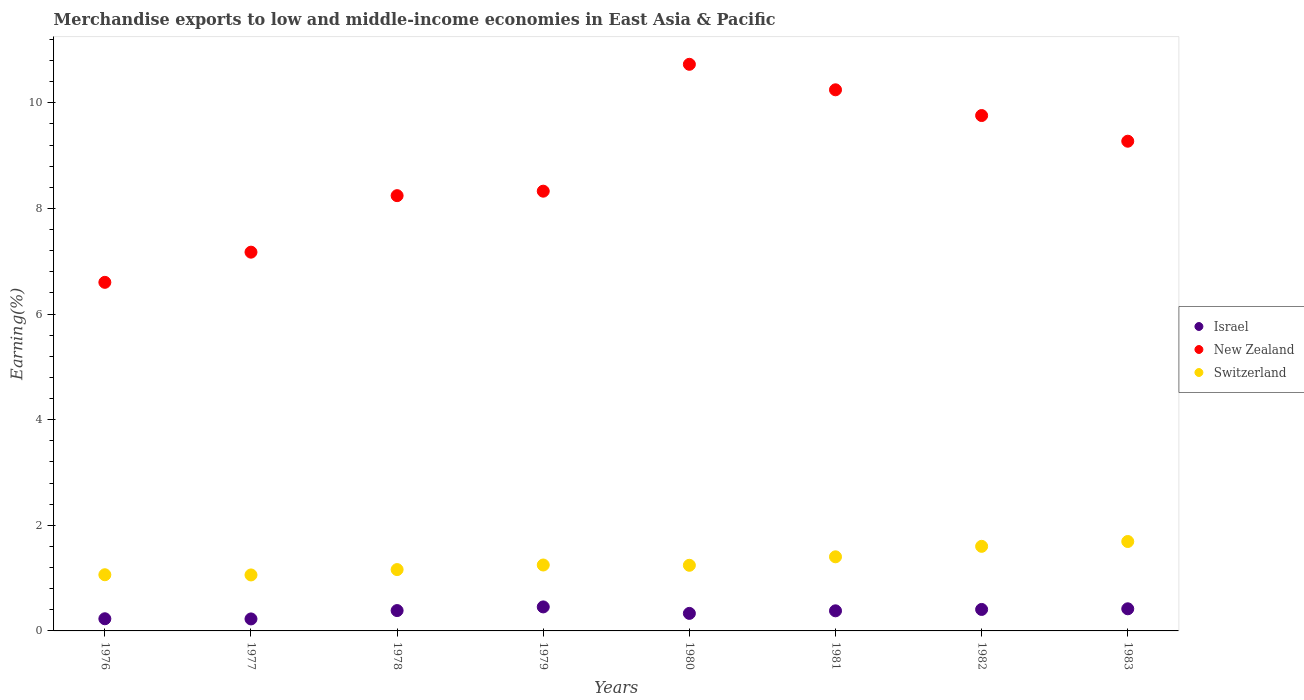How many different coloured dotlines are there?
Your response must be concise. 3. What is the percentage of amount earned from merchandise exports in Israel in 1978?
Make the answer very short. 0.39. Across all years, what is the maximum percentage of amount earned from merchandise exports in Switzerland?
Ensure brevity in your answer.  1.69. Across all years, what is the minimum percentage of amount earned from merchandise exports in Israel?
Keep it short and to the point. 0.23. In which year was the percentage of amount earned from merchandise exports in New Zealand maximum?
Your answer should be very brief. 1980. What is the total percentage of amount earned from merchandise exports in New Zealand in the graph?
Provide a short and direct response. 70.34. What is the difference between the percentage of amount earned from merchandise exports in Israel in 1976 and that in 1980?
Keep it short and to the point. -0.1. What is the difference between the percentage of amount earned from merchandise exports in New Zealand in 1979 and the percentage of amount earned from merchandise exports in Israel in 1981?
Your response must be concise. 7.95. What is the average percentage of amount earned from merchandise exports in Switzerland per year?
Give a very brief answer. 1.31. In the year 1983, what is the difference between the percentage of amount earned from merchandise exports in Israel and percentage of amount earned from merchandise exports in Switzerland?
Provide a short and direct response. -1.27. In how many years, is the percentage of amount earned from merchandise exports in New Zealand greater than 1.6 %?
Your response must be concise. 8. What is the ratio of the percentage of amount earned from merchandise exports in New Zealand in 1976 to that in 1979?
Your answer should be compact. 0.79. Is the percentage of amount earned from merchandise exports in New Zealand in 1978 less than that in 1979?
Provide a succinct answer. Yes. Is the difference between the percentage of amount earned from merchandise exports in Israel in 1977 and 1981 greater than the difference between the percentage of amount earned from merchandise exports in Switzerland in 1977 and 1981?
Offer a very short reply. Yes. What is the difference between the highest and the second highest percentage of amount earned from merchandise exports in New Zealand?
Your response must be concise. 0.48. What is the difference between the highest and the lowest percentage of amount earned from merchandise exports in Israel?
Provide a short and direct response. 0.23. Is the sum of the percentage of amount earned from merchandise exports in Israel in 1978 and 1979 greater than the maximum percentage of amount earned from merchandise exports in Switzerland across all years?
Your response must be concise. No. Is the percentage of amount earned from merchandise exports in Israel strictly greater than the percentage of amount earned from merchandise exports in Switzerland over the years?
Your answer should be compact. No. Is the percentage of amount earned from merchandise exports in New Zealand strictly less than the percentage of amount earned from merchandise exports in Israel over the years?
Give a very brief answer. No. How many years are there in the graph?
Provide a succinct answer. 8. What is the difference between two consecutive major ticks on the Y-axis?
Offer a terse response. 2. Does the graph contain any zero values?
Keep it short and to the point. No. Does the graph contain grids?
Give a very brief answer. No. How many legend labels are there?
Keep it short and to the point. 3. How are the legend labels stacked?
Make the answer very short. Vertical. What is the title of the graph?
Provide a short and direct response. Merchandise exports to low and middle-income economies in East Asia & Pacific. Does "Belarus" appear as one of the legend labels in the graph?
Your answer should be very brief. No. What is the label or title of the Y-axis?
Your answer should be compact. Earning(%). What is the Earning(%) of Israel in 1976?
Ensure brevity in your answer.  0.23. What is the Earning(%) of New Zealand in 1976?
Offer a terse response. 6.6. What is the Earning(%) in Switzerland in 1976?
Make the answer very short. 1.06. What is the Earning(%) of Israel in 1977?
Offer a terse response. 0.23. What is the Earning(%) in New Zealand in 1977?
Your response must be concise. 7.17. What is the Earning(%) of Switzerland in 1977?
Your answer should be very brief. 1.06. What is the Earning(%) in Israel in 1978?
Make the answer very short. 0.39. What is the Earning(%) of New Zealand in 1978?
Make the answer very short. 8.24. What is the Earning(%) in Switzerland in 1978?
Make the answer very short. 1.16. What is the Earning(%) of Israel in 1979?
Ensure brevity in your answer.  0.45. What is the Earning(%) in New Zealand in 1979?
Make the answer very short. 8.33. What is the Earning(%) in Switzerland in 1979?
Offer a very short reply. 1.25. What is the Earning(%) in Israel in 1980?
Your answer should be very brief. 0.33. What is the Earning(%) of New Zealand in 1980?
Provide a short and direct response. 10.73. What is the Earning(%) in Switzerland in 1980?
Give a very brief answer. 1.24. What is the Earning(%) in Israel in 1981?
Make the answer very short. 0.38. What is the Earning(%) of New Zealand in 1981?
Your answer should be compact. 10.25. What is the Earning(%) of Switzerland in 1981?
Your response must be concise. 1.4. What is the Earning(%) in Israel in 1982?
Provide a succinct answer. 0.41. What is the Earning(%) in New Zealand in 1982?
Offer a terse response. 9.76. What is the Earning(%) in Switzerland in 1982?
Provide a succinct answer. 1.6. What is the Earning(%) of Israel in 1983?
Make the answer very short. 0.42. What is the Earning(%) in New Zealand in 1983?
Offer a terse response. 9.27. What is the Earning(%) in Switzerland in 1983?
Offer a terse response. 1.69. Across all years, what is the maximum Earning(%) of Israel?
Ensure brevity in your answer.  0.45. Across all years, what is the maximum Earning(%) in New Zealand?
Your answer should be very brief. 10.73. Across all years, what is the maximum Earning(%) in Switzerland?
Make the answer very short. 1.69. Across all years, what is the minimum Earning(%) of Israel?
Ensure brevity in your answer.  0.23. Across all years, what is the minimum Earning(%) in New Zealand?
Offer a very short reply. 6.6. Across all years, what is the minimum Earning(%) of Switzerland?
Keep it short and to the point. 1.06. What is the total Earning(%) in Israel in the graph?
Your response must be concise. 2.84. What is the total Earning(%) of New Zealand in the graph?
Your answer should be very brief. 70.34. What is the total Earning(%) in Switzerland in the graph?
Keep it short and to the point. 10.47. What is the difference between the Earning(%) of Israel in 1976 and that in 1977?
Provide a short and direct response. 0. What is the difference between the Earning(%) in New Zealand in 1976 and that in 1977?
Make the answer very short. -0.57. What is the difference between the Earning(%) of Switzerland in 1976 and that in 1977?
Your answer should be very brief. 0. What is the difference between the Earning(%) of Israel in 1976 and that in 1978?
Give a very brief answer. -0.16. What is the difference between the Earning(%) in New Zealand in 1976 and that in 1978?
Provide a short and direct response. -1.64. What is the difference between the Earning(%) in Switzerland in 1976 and that in 1978?
Offer a very short reply. -0.1. What is the difference between the Earning(%) in Israel in 1976 and that in 1979?
Provide a succinct answer. -0.22. What is the difference between the Earning(%) in New Zealand in 1976 and that in 1979?
Make the answer very short. -1.73. What is the difference between the Earning(%) of Switzerland in 1976 and that in 1979?
Offer a terse response. -0.18. What is the difference between the Earning(%) of Israel in 1976 and that in 1980?
Offer a very short reply. -0.1. What is the difference between the Earning(%) of New Zealand in 1976 and that in 1980?
Keep it short and to the point. -4.13. What is the difference between the Earning(%) in Switzerland in 1976 and that in 1980?
Ensure brevity in your answer.  -0.18. What is the difference between the Earning(%) of Israel in 1976 and that in 1981?
Provide a short and direct response. -0.15. What is the difference between the Earning(%) in New Zealand in 1976 and that in 1981?
Make the answer very short. -3.65. What is the difference between the Earning(%) of Switzerland in 1976 and that in 1981?
Provide a short and direct response. -0.34. What is the difference between the Earning(%) of Israel in 1976 and that in 1982?
Provide a succinct answer. -0.18. What is the difference between the Earning(%) of New Zealand in 1976 and that in 1982?
Offer a terse response. -3.16. What is the difference between the Earning(%) of Switzerland in 1976 and that in 1982?
Give a very brief answer. -0.54. What is the difference between the Earning(%) of Israel in 1976 and that in 1983?
Keep it short and to the point. -0.19. What is the difference between the Earning(%) of New Zealand in 1976 and that in 1983?
Provide a succinct answer. -2.67. What is the difference between the Earning(%) in Switzerland in 1976 and that in 1983?
Offer a terse response. -0.63. What is the difference between the Earning(%) of Israel in 1977 and that in 1978?
Your answer should be very brief. -0.16. What is the difference between the Earning(%) in New Zealand in 1977 and that in 1978?
Make the answer very short. -1.07. What is the difference between the Earning(%) in Switzerland in 1977 and that in 1978?
Make the answer very short. -0.1. What is the difference between the Earning(%) of Israel in 1977 and that in 1979?
Provide a succinct answer. -0.23. What is the difference between the Earning(%) of New Zealand in 1977 and that in 1979?
Provide a short and direct response. -1.15. What is the difference between the Earning(%) of Switzerland in 1977 and that in 1979?
Give a very brief answer. -0.19. What is the difference between the Earning(%) of Israel in 1977 and that in 1980?
Keep it short and to the point. -0.1. What is the difference between the Earning(%) in New Zealand in 1977 and that in 1980?
Keep it short and to the point. -3.56. What is the difference between the Earning(%) of Switzerland in 1977 and that in 1980?
Offer a very short reply. -0.18. What is the difference between the Earning(%) in Israel in 1977 and that in 1981?
Provide a short and direct response. -0.15. What is the difference between the Earning(%) of New Zealand in 1977 and that in 1981?
Provide a short and direct response. -3.07. What is the difference between the Earning(%) of Switzerland in 1977 and that in 1981?
Ensure brevity in your answer.  -0.34. What is the difference between the Earning(%) in Israel in 1977 and that in 1982?
Offer a terse response. -0.18. What is the difference between the Earning(%) of New Zealand in 1977 and that in 1982?
Your answer should be compact. -2.59. What is the difference between the Earning(%) in Switzerland in 1977 and that in 1982?
Provide a short and direct response. -0.54. What is the difference between the Earning(%) of Israel in 1977 and that in 1983?
Provide a short and direct response. -0.19. What is the difference between the Earning(%) of New Zealand in 1977 and that in 1983?
Provide a short and direct response. -2.1. What is the difference between the Earning(%) in Switzerland in 1977 and that in 1983?
Provide a short and direct response. -0.63. What is the difference between the Earning(%) of Israel in 1978 and that in 1979?
Provide a short and direct response. -0.07. What is the difference between the Earning(%) of New Zealand in 1978 and that in 1979?
Offer a very short reply. -0.08. What is the difference between the Earning(%) in Switzerland in 1978 and that in 1979?
Provide a succinct answer. -0.09. What is the difference between the Earning(%) in Israel in 1978 and that in 1980?
Ensure brevity in your answer.  0.05. What is the difference between the Earning(%) in New Zealand in 1978 and that in 1980?
Make the answer very short. -2.49. What is the difference between the Earning(%) of Switzerland in 1978 and that in 1980?
Provide a succinct answer. -0.08. What is the difference between the Earning(%) in Israel in 1978 and that in 1981?
Provide a short and direct response. 0. What is the difference between the Earning(%) in New Zealand in 1978 and that in 1981?
Your response must be concise. -2. What is the difference between the Earning(%) in Switzerland in 1978 and that in 1981?
Offer a terse response. -0.24. What is the difference between the Earning(%) of Israel in 1978 and that in 1982?
Keep it short and to the point. -0.02. What is the difference between the Earning(%) in New Zealand in 1978 and that in 1982?
Make the answer very short. -1.52. What is the difference between the Earning(%) in Switzerland in 1978 and that in 1982?
Offer a very short reply. -0.44. What is the difference between the Earning(%) in Israel in 1978 and that in 1983?
Offer a terse response. -0.03. What is the difference between the Earning(%) in New Zealand in 1978 and that in 1983?
Your answer should be compact. -1.03. What is the difference between the Earning(%) in Switzerland in 1978 and that in 1983?
Offer a very short reply. -0.53. What is the difference between the Earning(%) in Israel in 1979 and that in 1980?
Ensure brevity in your answer.  0.12. What is the difference between the Earning(%) of New Zealand in 1979 and that in 1980?
Offer a very short reply. -2.4. What is the difference between the Earning(%) in Switzerland in 1979 and that in 1980?
Keep it short and to the point. 0.01. What is the difference between the Earning(%) in Israel in 1979 and that in 1981?
Your answer should be compact. 0.07. What is the difference between the Earning(%) in New Zealand in 1979 and that in 1981?
Your answer should be very brief. -1.92. What is the difference between the Earning(%) of Switzerland in 1979 and that in 1981?
Provide a succinct answer. -0.16. What is the difference between the Earning(%) in Israel in 1979 and that in 1982?
Provide a succinct answer. 0.05. What is the difference between the Earning(%) in New Zealand in 1979 and that in 1982?
Provide a short and direct response. -1.43. What is the difference between the Earning(%) in Switzerland in 1979 and that in 1982?
Your answer should be compact. -0.35. What is the difference between the Earning(%) of Israel in 1979 and that in 1983?
Your response must be concise. 0.04. What is the difference between the Earning(%) of New Zealand in 1979 and that in 1983?
Offer a very short reply. -0.95. What is the difference between the Earning(%) of Switzerland in 1979 and that in 1983?
Your answer should be very brief. -0.44. What is the difference between the Earning(%) in Israel in 1980 and that in 1981?
Provide a short and direct response. -0.05. What is the difference between the Earning(%) of New Zealand in 1980 and that in 1981?
Provide a short and direct response. 0.48. What is the difference between the Earning(%) in Switzerland in 1980 and that in 1981?
Ensure brevity in your answer.  -0.16. What is the difference between the Earning(%) in Israel in 1980 and that in 1982?
Provide a short and direct response. -0.07. What is the difference between the Earning(%) in New Zealand in 1980 and that in 1982?
Provide a short and direct response. 0.97. What is the difference between the Earning(%) of Switzerland in 1980 and that in 1982?
Provide a succinct answer. -0.36. What is the difference between the Earning(%) of Israel in 1980 and that in 1983?
Your response must be concise. -0.09. What is the difference between the Earning(%) in New Zealand in 1980 and that in 1983?
Your answer should be compact. 1.46. What is the difference between the Earning(%) in Switzerland in 1980 and that in 1983?
Offer a very short reply. -0.45. What is the difference between the Earning(%) in Israel in 1981 and that in 1982?
Your answer should be compact. -0.03. What is the difference between the Earning(%) in New Zealand in 1981 and that in 1982?
Provide a succinct answer. 0.49. What is the difference between the Earning(%) of Switzerland in 1981 and that in 1982?
Offer a very short reply. -0.2. What is the difference between the Earning(%) in Israel in 1981 and that in 1983?
Keep it short and to the point. -0.04. What is the difference between the Earning(%) of New Zealand in 1981 and that in 1983?
Offer a very short reply. 0.97. What is the difference between the Earning(%) in Switzerland in 1981 and that in 1983?
Give a very brief answer. -0.29. What is the difference between the Earning(%) in Israel in 1982 and that in 1983?
Offer a very short reply. -0.01. What is the difference between the Earning(%) of New Zealand in 1982 and that in 1983?
Ensure brevity in your answer.  0.49. What is the difference between the Earning(%) of Switzerland in 1982 and that in 1983?
Your answer should be compact. -0.09. What is the difference between the Earning(%) in Israel in 1976 and the Earning(%) in New Zealand in 1977?
Offer a very short reply. -6.94. What is the difference between the Earning(%) of Israel in 1976 and the Earning(%) of Switzerland in 1977?
Offer a terse response. -0.83. What is the difference between the Earning(%) in New Zealand in 1976 and the Earning(%) in Switzerland in 1977?
Your response must be concise. 5.54. What is the difference between the Earning(%) in Israel in 1976 and the Earning(%) in New Zealand in 1978?
Your response must be concise. -8.01. What is the difference between the Earning(%) in Israel in 1976 and the Earning(%) in Switzerland in 1978?
Your answer should be compact. -0.93. What is the difference between the Earning(%) in New Zealand in 1976 and the Earning(%) in Switzerland in 1978?
Offer a terse response. 5.44. What is the difference between the Earning(%) of Israel in 1976 and the Earning(%) of New Zealand in 1979?
Offer a very short reply. -8.1. What is the difference between the Earning(%) in Israel in 1976 and the Earning(%) in Switzerland in 1979?
Your response must be concise. -1.02. What is the difference between the Earning(%) in New Zealand in 1976 and the Earning(%) in Switzerland in 1979?
Ensure brevity in your answer.  5.35. What is the difference between the Earning(%) of Israel in 1976 and the Earning(%) of New Zealand in 1980?
Your answer should be compact. -10.5. What is the difference between the Earning(%) in Israel in 1976 and the Earning(%) in Switzerland in 1980?
Your answer should be compact. -1.01. What is the difference between the Earning(%) of New Zealand in 1976 and the Earning(%) of Switzerland in 1980?
Provide a succinct answer. 5.36. What is the difference between the Earning(%) in Israel in 1976 and the Earning(%) in New Zealand in 1981?
Provide a short and direct response. -10.02. What is the difference between the Earning(%) in Israel in 1976 and the Earning(%) in Switzerland in 1981?
Offer a terse response. -1.17. What is the difference between the Earning(%) of New Zealand in 1976 and the Earning(%) of Switzerland in 1981?
Ensure brevity in your answer.  5.2. What is the difference between the Earning(%) in Israel in 1976 and the Earning(%) in New Zealand in 1982?
Keep it short and to the point. -9.53. What is the difference between the Earning(%) in Israel in 1976 and the Earning(%) in Switzerland in 1982?
Give a very brief answer. -1.37. What is the difference between the Earning(%) of New Zealand in 1976 and the Earning(%) of Switzerland in 1982?
Provide a short and direct response. 5. What is the difference between the Earning(%) of Israel in 1976 and the Earning(%) of New Zealand in 1983?
Give a very brief answer. -9.04. What is the difference between the Earning(%) of Israel in 1976 and the Earning(%) of Switzerland in 1983?
Offer a terse response. -1.46. What is the difference between the Earning(%) in New Zealand in 1976 and the Earning(%) in Switzerland in 1983?
Your response must be concise. 4.91. What is the difference between the Earning(%) in Israel in 1977 and the Earning(%) in New Zealand in 1978?
Your answer should be compact. -8.01. What is the difference between the Earning(%) of Israel in 1977 and the Earning(%) of Switzerland in 1978?
Offer a very short reply. -0.93. What is the difference between the Earning(%) in New Zealand in 1977 and the Earning(%) in Switzerland in 1978?
Ensure brevity in your answer.  6.01. What is the difference between the Earning(%) in Israel in 1977 and the Earning(%) in New Zealand in 1979?
Provide a succinct answer. -8.1. What is the difference between the Earning(%) in Israel in 1977 and the Earning(%) in Switzerland in 1979?
Give a very brief answer. -1.02. What is the difference between the Earning(%) in New Zealand in 1977 and the Earning(%) in Switzerland in 1979?
Your answer should be very brief. 5.92. What is the difference between the Earning(%) of Israel in 1977 and the Earning(%) of New Zealand in 1980?
Your response must be concise. -10.5. What is the difference between the Earning(%) in Israel in 1977 and the Earning(%) in Switzerland in 1980?
Give a very brief answer. -1.02. What is the difference between the Earning(%) of New Zealand in 1977 and the Earning(%) of Switzerland in 1980?
Your answer should be compact. 5.93. What is the difference between the Earning(%) in Israel in 1977 and the Earning(%) in New Zealand in 1981?
Make the answer very short. -10.02. What is the difference between the Earning(%) of Israel in 1977 and the Earning(%) of Switzerland in 1981?
Your answer should be compact. -1.18. What is the difference between the Earning(%) of New Zealand in 1977 and the Earning(%) of Switzerland in 1981?
Offer a very short reply. 5.77. What is the difference between the Earning(%) of Israel in 1977 and the Earning(%) of New Zealand in 1982?
Your response must be concise. -9.53. What is the difference between the Earning(%) in Israel in 1977 and the Earning(%) in Switzerland in 1982?
Provide a succinct answer. -1.37. What is the difference between the Earning(%) in New Zealand in 1977 and the Earning(%) in Switzerland in 1982?
Give a very brief answer. 5.57. What is the difference between the Earning(%) of Israel in 1977 and the Earning(%) of New Zealand in 1983?
Your response must be concise. -9.04. What is the difference between the Earning(%) of Israel in 1977 and the Earning(%) of Switzerland in 1983?
Your response must be concise. -1.47. What is the difference between the Earning(%) of New Zealand in 1977 and the Earning(%) of Switzerland in 1983?
Keep it short and to the point. 5.48. What is the difference between the Earning(%) of Israel in 1978 and the Earning(%) of New Zealand in 1979?
Keep it short and to the point. -7.94. What is the difference between the Earning(%) in Israel in 1978 and the Earning(%) in Switzerland in 1979?
Make the answer very short. -0.86. What is the difference between the Earning(%) of New Zealand in 1978 and the Earning(%) of Switzerland in 1979?
Provide a succinct answer. 6.99. What is the difference between the Earning(%) of Israel in 1978 and the Earning(%) of New Zealand in 1980?
Your response must be concise. -10.34. What is the difference between the Earning(%) in Israel in 1978 and the Earning(%) in Switzerland in 1980?
Your answer should be compact. -0.86. What is the difference between the Earning(%) in New Zealand in 1978 and the Earning(%) in Switzerland in 1980?
Give a very brief answer. 7. What is the difference between the Earning(%) in Israel in 1978 and the Earning(%) in New Zealand in 1981?
Keep it short and to the point. -9.86. What is the difference between the Earning(%) in Israel in 1978 and the Earning(%) in Switzerland in 1981?
Give a very brief answer. -1.02. What is the difference between the Earning(%) in New Zealand in 1978 and the Earning(%) in Switzerland in 1981?
Give a very brief answer. 6.84. What is the difference between the Earning(%) of Israel in 1978 and the Earning(%) of New Zealand in 1982?
Keep it short and to the point. -9.37. What is the difference between the Earning(%) in Israel in 1978 and the Earning(%) in Switzerland in 1982?
Your response must be concise. -1.22. What is the difference between the Earning(%) in New Zealand in 1978 and the Earning(%) in Switzerland in 1982?
Make the answer very short. 6.64. What is the difference between the Earning(%) in Israel in 1978 and the Earning(%) in New Zealand in 1983?
Offer a terse response. -8.89. What is the difference between the Earning(%) of Israel in 1978 and the Earning(%) of Switzerland in 1983?
Your response must be concise. -1.31. What is the difference between the Earning(%) in New Zealand in 1978 and the Earning(%) in Switzerland in 1983?
Your response must be concise. 6.55. What is the difference between the Earning(%) in Israel in 1979 and the Earning(%) in New Zealand in 1980?
Your answer should be compact. -10.27. What is the difference between the Earning(%) of Israel in 1979 and the Earning(%) of Switzerland in 1980?
Ensure brevity in your answer.  -0.79. What is the difference between the Earning(%) of New Zealand in 1979 and the Earning(%) of Switzerland in 1980?
Your answer should be compact. 7.08. What is the difference between the Earning(%) in Israel in 1979 and the Earning(%) in New Zealand in 1981?
Keep it short and to the point. -9.79. What is the difference between the Earning(%) in Israel in 1979 and the Earning(%) in Switzerland in 1981?
Make the answer very short. -0.95. What is the difference between the Earning(%) in New Zealand in 1979 and the Earning(%) in Switzerland in 1981?
Your response must be concise. 6.92. What is the difference between the Earning(%) in Israel in 1979 and the Earning(%) in New Zealand in 1982?
Ensure brevity in your answer.  -9.3. What is the difference between the Earning(%) of Israel in 1979 and the Earning(%) of Switzerland in 1982?
Offer a terse response. -1.15. What is the difference between the Earning(%) of New Zealand in 1979 and the Earning(%) of Switzerland in 1982?
Your answer should be compact. 6.72. What is the difference between the Earning(%) of Israel in 1979 and the Earning(%) of New Zealand in 1983?
Make the answer very short. -8.82. What is the difference between the Earning(%) in Israel in 1979 and the Earning(%) in Switzerland in 1983?
Provide a succinct answer. -1.24. What is the difference between the Earning(%) of New Zealand in 1979 and the Earning(%) of Switzerland in 1983?
Offer a very short reply. 6.63. What is the difference between the Earning(%) in Israel in 1980 and the Earning(%) in New Zealand in 1981?
Your answer should be very brief. -9.91. What is the difference between the Earning(%) of Israel in 1980 and the Earning(%) of Switzerland in 1981?
Your response must be concise. -1.07. What is the difference between the Earning(%) in New Zealand in 1980 and the Earning(%) in Switzerland in 1981?
Provide a succinct answer. 9.32. What is the difference between the Earning(%) in Israel in 1980 and the Earning(%) in New Zealand in 1982?
Provide a short and direct response. -9.43. What is the difference between the Earning(%) in Israel in 1980 and the Earning(%) in Switzerland in 1982?
Your answer should be compact. -1.27. What is the difference between the Earning(%) in New Zealand in 1980 and the Earning(%) in Switzerland in 1982?
Your response must be concise. 9.13. What is the difference between the Earning(%) of Israel in 1980 and the Earning(%) of New Zealand in 1983?
Offer a very short reply. -8.94. What is the difference between the Earning(%) of Israel in 1980 and the Earning(%) of Switzerland in 1983?
Make the answer very short. -1.36. What is the difference between the Earning(%) of New Zealand in 1980 and the Earning(%) of Switzerland in 1983?
Provide a short and direct response. 9.04. What is the difference between the Earning(%) in Israel in 1981 and the Earning(%) in New Zealand in 1982?
Your answer should be very brief. -9.38. What is the difference between the Earning(%) in Israel in 1981 and the Earning(%) in Switzerland in 1982?
Provide a short and direct response. -1.22. What is the difference between the Earning(%) in New Zealand in 1981 and the Earning(%) in Switzerland in 1982?
Keep it short and to the point. 8.64. What is the difference between the Earning(%) of Israel in 1981 and the Earning(%) of New Zealand in 1983?
Provide a short and direct response. -8.89. What is the difference between the Earning(%) of Israel in 1981 and the Earning(%) of Switzerland in 1983?
Give a very brief answer. -1.31. What is the difference between the Earning(%) of New Zealand in 1981 and the Earning(%) of Switzerland in 1983?
Give a very brief answer. 8.55. What is the difference between the Earning(%) of Israel in 1982 and the Earning(%) of New Zealand in 1983?
Offer a terse response. -8.87. What is the difference between the Earning(%) in Israel in 1982 and the Earning(%) in Switzerland in 1983?
Your response must be concise. -1.29. What is the difference between the Earning(%) in New Zealand in 1982 and the Earning(%) in Switzerland in 1983?
Make the answer very short. 8.07. What is the average Earning(%) of Israel per year?
Offer a very short reply. 0.35. What is the average Earning(%) of New Zealand per year?
Offer a terse response. 8.79. What is the average Earning(%) of Switzerland per year?
Keep it short and to the point. 1.31. In the year 1976, what is the difference between the Earning(%) of Israel and Earning(%) of New Zealand?
Your response must be concise. -6.37. In the year 1976, what is the difference between the Earning(%) of Israel and Earning(%) of Switzerland?
Provide a succinct answer. -0.83. In the year 1976, what is the difference between the Earning(%) of New Zealand and Earning(%) of Switzerland?
Keep it short and to the point. 5.54. In the year 1977, what is the difference between the Earning(%) of Israel and Earning(%) of New Zealand?
Offer a terse response. -6.94. In the year 1977, what is the difference between the Earning(%) of Israel and Earning(%) of Switzerland?
Provide a short and direct response. -0.83. In the year 1977, what is the difference between the Earning(%) of New Zealand and Earning(%) of Switzerland?
Provide a short and direct response. 6.11. In the year 1978, what is the difference between the Earning(%) of Israel and Earning(%) of New Zealand?
Ensure brevity in your answer.  -7.86. In the year 1978, what is the difference between the Earning(%) in Israel and Earning(%) in Switzerland?
Offer a very short reply. -0.78. In the year 1978, what is the difference between the Earning(%) in New Zealand and Earning(%) in Switzerland?
Offer a terse response. 7.08. In the year 1979, what is the difference between the Earning(%) in Israel and Earning(%) in New Zealand?
Provide a short and direct response. -7.87. In the year 1979, what is the difference between the Earning(%) in Israel and Earning(%) in Switzerland?
Keep it short and to the point. -0.79. In the year 1979, what is the difference between the Earning(%) of New Zealand and Earning(%) of Switzerland?
Provide a short and direct response. 7.08. In the year 1980, what is the difference between the Earning(%) in Israel and Earning(%) in New Zealand?
Offer a very short reply. -10.4. In the year 1980, what is the difference between the Earning(%) of Israel and Earning(%) of Switzerland?
Ensure brevity in your answer.  -0.91. In the year 1980, what is the difference between the Earning(%) in New Zealand and Earning(%) in Switzerland?
Your answer should be compact. 9.49. In the year 1981, what is the difference between the Earning(%) in Israel and Earning(%) in New Zealand?
Give a very brief answer. -9.86. In the year 1981, what is the difference between the Earning(%) of Israel and Earning(%) of Switzerland?
Offer a terse response. -1.02. In the year 1981, what is the difference between the Earning(%) of New Zealand and Earning(%) of Switzerland?
Provide a succinct answer. 8.84. In the year 1982, what is the difference between the Earning(%) of Israel and Earning(%) of New Zealand?
Offer a terse response. -9.35. In the year 1982, what is the difference between the Earning(%) of Israel and Earning(%) of Switzerland?
Offer a terse response. -1.19. In the year 1982, what is the difference between the Earning(%) of New Zealand and Earning(%) of Switzerland?
Keep it short and to the point. 8.16. In the year 1983, what is the difference between the Earning(%) in Israel and Earning(%) in New Zealand?
Offer a very short reply. -8.85. In the year 1983, what is the difference between the Earning(%) of Israel and Earning(%) of Switzerland?
Make the answer very short. -1.27. In the year 1983, what is the difference between the Earning(%) of New Zealand and Earning(%) of Switzerland?
Keep it short and to the point. 7.58. What is the ratio of the Earning(%) of Israel in 1976 to that in 1977?
Give a very brief answer. 1.01. What is the ratio of the Earning(%) of New Zealand in 1976 to that in 1977?
Make the answer very short. 0.92. What is the ratio of the Earning(%) of Israel in 1976 to that in 1978?
Provide a succinct answer. 0.6. What is the ratio of the Earning(%) of New Zealand in 1976 to that in 1978?
Your response must be concise. 0.8. What is the ratio of the Earning(%) of Switzerland in 1976 to that in 1978?
Give a very brief answer. 0.92. What is the ratio of the Earning(%) of Israel in 1976 to that in 1979?
Provide a short and direct response. 0.51. What is the ratio of the Earning(%) in New Zealand in 1976 to that in 1979?
Your answer should be very brief. 0.79. What is the ratio of the Earning(%) in Switzerland in 1976 to that in 1979?
Offer a very short reply. 0.85. What is the ratio of the Earning(%) in Israel in 1976 to that in 1980?
Offer a very short reply. 0.69. What is the ratio of the Earning(%) of New Zealand in 1976 to that in 1980?
Your answer should be compact. 0.62. What is the ratio of the Earning(%) in Switzerland in 1976 to that in 1980?
Your response must be concise. 0.86. What is the ratio of the Earning(%) in Israel in 1976 to that in 1981?
Keep it short and to the point. 0.6. What is the ratio of the Earning(%) of New Zealand in 1976 to that in 1981?
Offer a very short reply. 0.64. What is the ratio of the Earning(%) of Switzerland in 1976 to that in 1981?
Provide a short and direct response. 0.76. What is the ratio of the Earning(%) in Israel in 1976 to that in 1982?
Provide a short and direct response. 0.57. What is the ratio of the Earning(%) of New Zealand in 1976 to that in 1982?
Your response must be concise. 0.68. What is the ratio of the Earning(%) of Switzerland in 1976 to that in 1982?
Give a very brief answer. 0.66. What is the ratio of the Earning(%) of Israel in 1976 to that in 1983?
Offer a terse response. 0.55. What is the ratio of the Earning(%) of New Zealand in 1976 to that in 1983?
Your answer should be compact. 0.71. What is the ratio of the Earning(%) in Switzerland in 1976 to that in 1983?
Keep it short and to the point. 0.63. What is the ratio of the Earning(%) in Israel in 1977 to that in 1978?
Your answer should be very brief. 0.59. What is the ratio of the Earning(%) of New Zealand in 1977 to that in 1978?
Provide a succinct answer. 0.87. What is the ratio of the Earning(%) of Switzerland in 1977 to that in 1978?
Provide a succinct answer. 0.91. What is the ratio of the Earning(%) in Israel in 1977 to that in 1979?
Offer a very short reply. 0.5. What is the ratio of the Earning(%) in New Zealand in 1977 to that in 1979?
Provide a succinct answer. 0.86. What is the ratio of the Earning(%) of Switzerland in 1977 to that in 1979?
Offer a very short reply. 0.85. What is the ratio of the Earning(%) of Israel in 1977 to that in 1980?
Offer a terse response. 0.68. What is the ratio of the Earning(%) of New Zealand in 1977 to that in 1980?
Offer a very short reply. 0.67. What is the ratio of the Earning(%) in Switzerland in 1977 to that in 1980?
Your response must be concise. 0.85. What is the ratio of the Earning(%) of Israel in 1977 to that in 1981?
Your response must be concise. 0.6. What is the ratio of the Earning(%) of Switzerland in 1977 to that in 1981?
Your answer should be compact. 0.76. What is the ratio of the Earning(%) of Israel in 1977 to that in 1982?
Make the answer very short. 0.56. What is the ratio of the Earning(%) of New Zealand in 1977 to that in 1982?
Your answer should be very brief. 0.73. What is the ratio of the Earning(%) of Switzerland in 1977 to that in 1982?
Ensure brevity in your answer.  0.66. What is the ratio of the Earning(%) of Israel in 1977 to that in 1983?
Offer a terse response. 0.54. What is the ratio of the Earning(%) of New Zealand in 1977 to that in 1983?
Make the answer very short. 0.77. What is the ratio of the Earning(%) in Switzerland in 1977 to that in 1983?
Give a very brief answer. 0.63. What is the ratio of the Earning(%) in Israel in 1978 to that in 1979?
Your answer should be compact. 0.85. What is the ratio of the Earning(%) in New Zealand in 1978 to that in 1979?
Offer a terse response. 0.99. What is the ratio of the Earning(%) in Switzerland in 1978 to that in 1979?
Your answer should be very brief. 0.93. What is the ratio of the Earning(%) of Israel in 1978 to that in 1980?
Provide a short and direct response. 1.16. What is the ratio of the Earning(%) of New Zealand in 1978 to that in 1980?
Your response must be concise. 0.77. What is the ratio of the Earning(%) in Switzerland in 1978 to that in 1980?
Offer a terse response. 0.93. What is the ratio of the Earning(%) in Israel in 1978 to that in 1981?
Make the answer very short. 1.01. What is the ratio of the Earning(%) of New Zealand in 1978 to that in 1981?
Give a very brief answer. 0.8. What is the ratio of the Earning(%) of Switzerland in 1978 to that in 1981?
Offer a terse response. 0.83. What is the ratio of the Earning(%) of Israel in 1978 to that in 1982?
Your answer should be very brief. 0.95. What is the ratio of the Earning(%) of New Zealand in 1978 to that in 1982?
Your response must be concise. 0.84. What is the ratio of the Earning(%) in Switzerland in 1978 to that in 1982?
Offer a very short reply. 0.73. What is the ratio of the Earning(%) in Israel in 1978 to that in 1983?
Offer a terse response. 0.92. What is the ratio of the Earning(%) in New Zealand in 1978 to that in 1983?
Provide a short and direct response. 0.89. What is the ratio of the Earning(%) of Switzerland in 1978 to that in 1983?
Offer a very short reply. 0.69. What is the ratio of the Earning(%) of Israel in 1979 to that in 1980?
Make the answer very short. 1.37. What is the ratio of the Earning(%) of New Zealand in 1979 to that in 1980?
Give a very brief answer. 0.78. What is the ratio of the Earning(%) in Switzerland in 1979 to that in 1980?
Provide a succinct answer. 1. What is the ratio of the Earning(%) of Israel in 1979 to that in 1981?
Give a very brief answer. 1.19. What is the ratio of the Earning(%) in New Zealand in 1979 to that in 1981?
Make the answer very short. 0.81. What is the ratio of the Earning(%) in Switzerland in 1979 to that in 1981?
Offer a terse response. 0.89. What is the ratio of the Earning(%) in Israel in 1979 to that in 1982?
Offer a very short reply. 1.12. What is the ratio of the Earning(%) of New Zealand in 1979 to that in 1982?
Keep it short and to the point. 0.85. What is the ratio of the Earning(%) in Switzerland in 1979 to that in 1982?
Provide a succinct answer. 0.78. What is the ratio of the Earning(%) in Israel in 1979 to that in 1983?
Provide a short and direct response. 1.09. What is the ratio of the Earning(%) in New Zealand in 1979 to that in 1983?
Your answer should be very brief. 0.9. What is the ratio of the Earning(%) in Switzerland in 1979 to that in 1983?
Your response must be concise. 0.74. What is the ratio of the Earning(%) in Israel in 1980 to that in 1981?
Your answer should be very brief. 0.87. What is the ratio of the Earning(%) of New Zealand in 1980 to that in 1981?
Give a very brief answer. 1.05. What is the ratio of the Earning(%) of Switzerland in 1980 to that in 1981?
Your response must be concise. 0.89. What is the ratio of the Earning(%) of Israel in 1980 to that in 1982?
Offer a terse response. 0.82. What is the ratio of the Earning(%) in New Zealand in 1980 to that in 1982?
Offer a very short reply. 1.1. What is the ratio of the Earning(%) of Switzerland in 1980 to that in 1982?
Offer a very short reply. 0.78. What is the ratio of the Earning(%) of Israel in 1980 to that in 1983?
Keep it short and to the point. 0.79. What is the ratio of the Earning(%) in New Zealand in 1980 to that in 1983?
Your answer should be very brief. 1.16. What is the ratio of the Earning(%) of Switzerland in 1980 to that in 1983?
Keep it short and to the point. 0.73. What is the ratio of the Earning(%) in Israel in 1981 to that in 1982?
Give a very brief answer. 0.94. What is the ratio of the Earning(%) in New Zealand in 1981 to that in 1982?
Keep it short and to the point. 1.05. What is the ratio of the Earning(%) of Switzerland in 1981 to that in 1982?
Make the answer very short. 0.88. What is the ratio of the Earning(%) of Israel in 1981 to that in 1983?
Make the answer very short. 0.91. What is the ratio of the Earning(%) in New Zealand in 1981 to that in 1983?
Ensure brevity in your answer.  1.1. What is the ratio of the Earning(%) in Switzerland in 1981 to that in 1983?
Provide a succinct answer. 0.83. What is the ratio of the Earning(%) in Israel in 1982 to that in 1983?
Your answer should be compact. 0.97. What is the ratio of the Earning(%) in New Zealand in 1982 to that in 1983?
Make the answer very short. 1.05. What is the ratio of the Earning(%) in Switzerland in 1982 to that in 1983?
Make the answer very short. 0.95. What is the difference between the highest and the second highest Earning(%) of Israel?
Provide a short and direct response. 0.04. What is the difference between the highest and the second highest Earning(%) of New Zealand?
Give a very brief answer. 0.48. What is the difference between the highest and the second highest Earning(%) in Switzerland?
Ensure brevity in your answer.  0.09. What is the difference between the highest and the lowest Earning(%) in Israel?
Provide a succinct answer. 0.23. What is the difference between the highest and the lowest Earning(%) in New Zealand?
Offer a very short reply. 4.13. What is the difference between the highest and the lowest Earning(%) in Switzerland?
Ensure brevity in your answer.  0.63. 